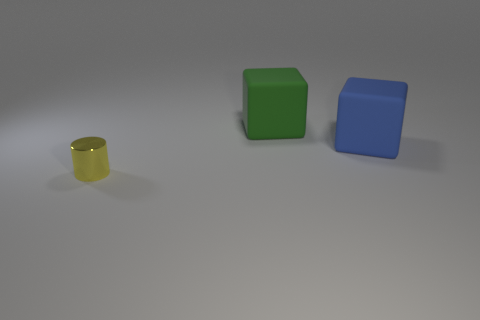Subtract all gray cylinders. Subtract all blue cubes. How many cylinders are left? 1 Add 2 blue matte objects. How many objects exist? 5 Subtract all cubes. How many objects are left? 1 Add 1 green things. How many green things are left? 2 Add 3 green matte objects. How many green matte objects exist? 4 Subtract 0 gray spheres. How many objects are left? 3 Subtract all large things. Subtract all big blue shiny things. How many objects are left? 1 